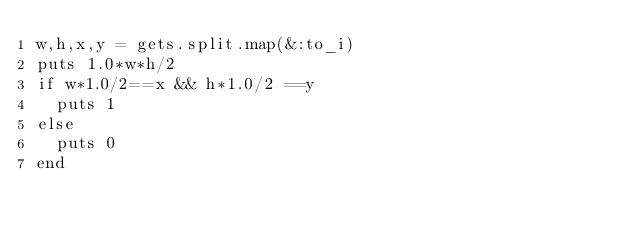<code> <loc_0><loc_0><loc_500><loc_500><_Ruby_>w,h,x,y = gets.split.map(&:to_i)
puts 1.0*w*h/2
if w*1.0/2==x && h*1.0/2 ==y
  puts 1
else
  puts 0
end</code> 